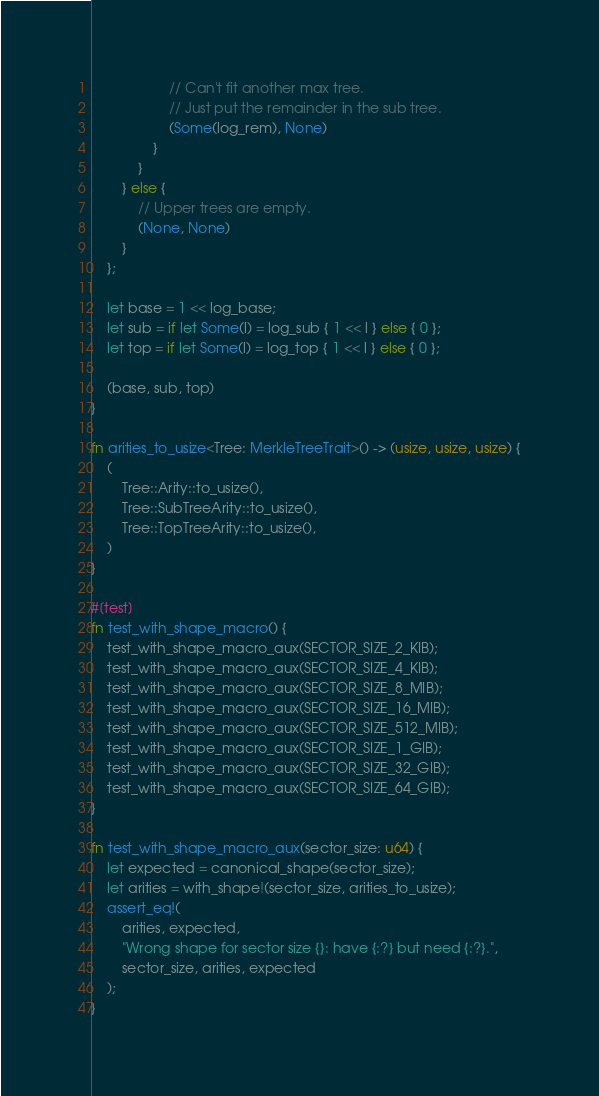<code> <loc_0><loc_0><loc_500><loc_500><_Rust_>                    // Can't fit another max tree.
                    // Just put the remainder in the sub tree.
                    (Some(log_rem), None)
                }
            }
        } else {
            // Upper trees are empty.
            (None, None)
        }
    };

    let base = 1 << log_base;
    let sub = if let Some(l) = log_sub { 1 << l } else { 0 };
    let top = if let Some(l) = log_top { 1 << l } else { 0 };

    (base, sub, top)
}

fn arities_to_usize<Tree: MerkleTreeTrait>() -> (usize, usize, usize) {
    (
        Tree::Arity::to_usize(),
        Tree::SubTreeArity::to_usize(),
        Tree::TopTreeArity::to_usize(),
    )
}

#[test]
fn test_with_shape_macro() {
    test_with_shape_macro_aux(SECTOR_SIZE_2_KIB);
    test_with_shape_macro_aux(SECTOR_SIZE_4_KIB);
    test_with_shape_macro_aux(SECTOR_SIZE_8_MIB);
    test_with_shape_macro_aux(SECTOR_SIZE_16_MIB);
    test_with_shape_macro_aux(SECTOR_SIZE_512_MIB);
    test_with_shape_macro_aux(SECTOR_SIZE_1_GIB);
    test_with_shape_macro_aux(SECTOR_SIZE_32_GIB);
    test_with_shape_macro_aux(SECTOR_SIZE_64_GIB);
}

fn test_with_shape_macro_aux(sector_size: u64) {
    let expected = canonical_shape(sector_size);
    let arities = with_shape!(sector_size, arities_to_usize);
    assert_eq!(
        arities, expected,
        "Wrong shape for sector size {}: have {:?} but need {:?}.",
        sector_size, arities, expected
    );
}
</code> 